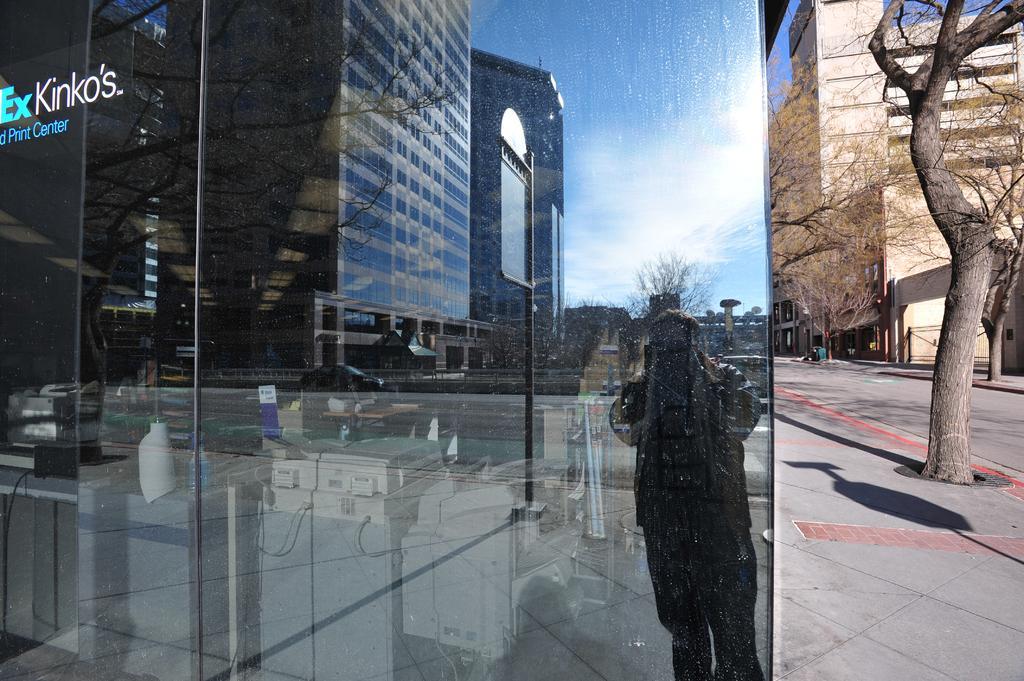Describe this image in one or two sentences. In this image we can see the inner view of a building. In the building there are printers, desktops, table lamp and the reflections of person standing on the road, trees, buildings and sky on the mirror. In the background there are buildings, trees, trash bins and sky. 